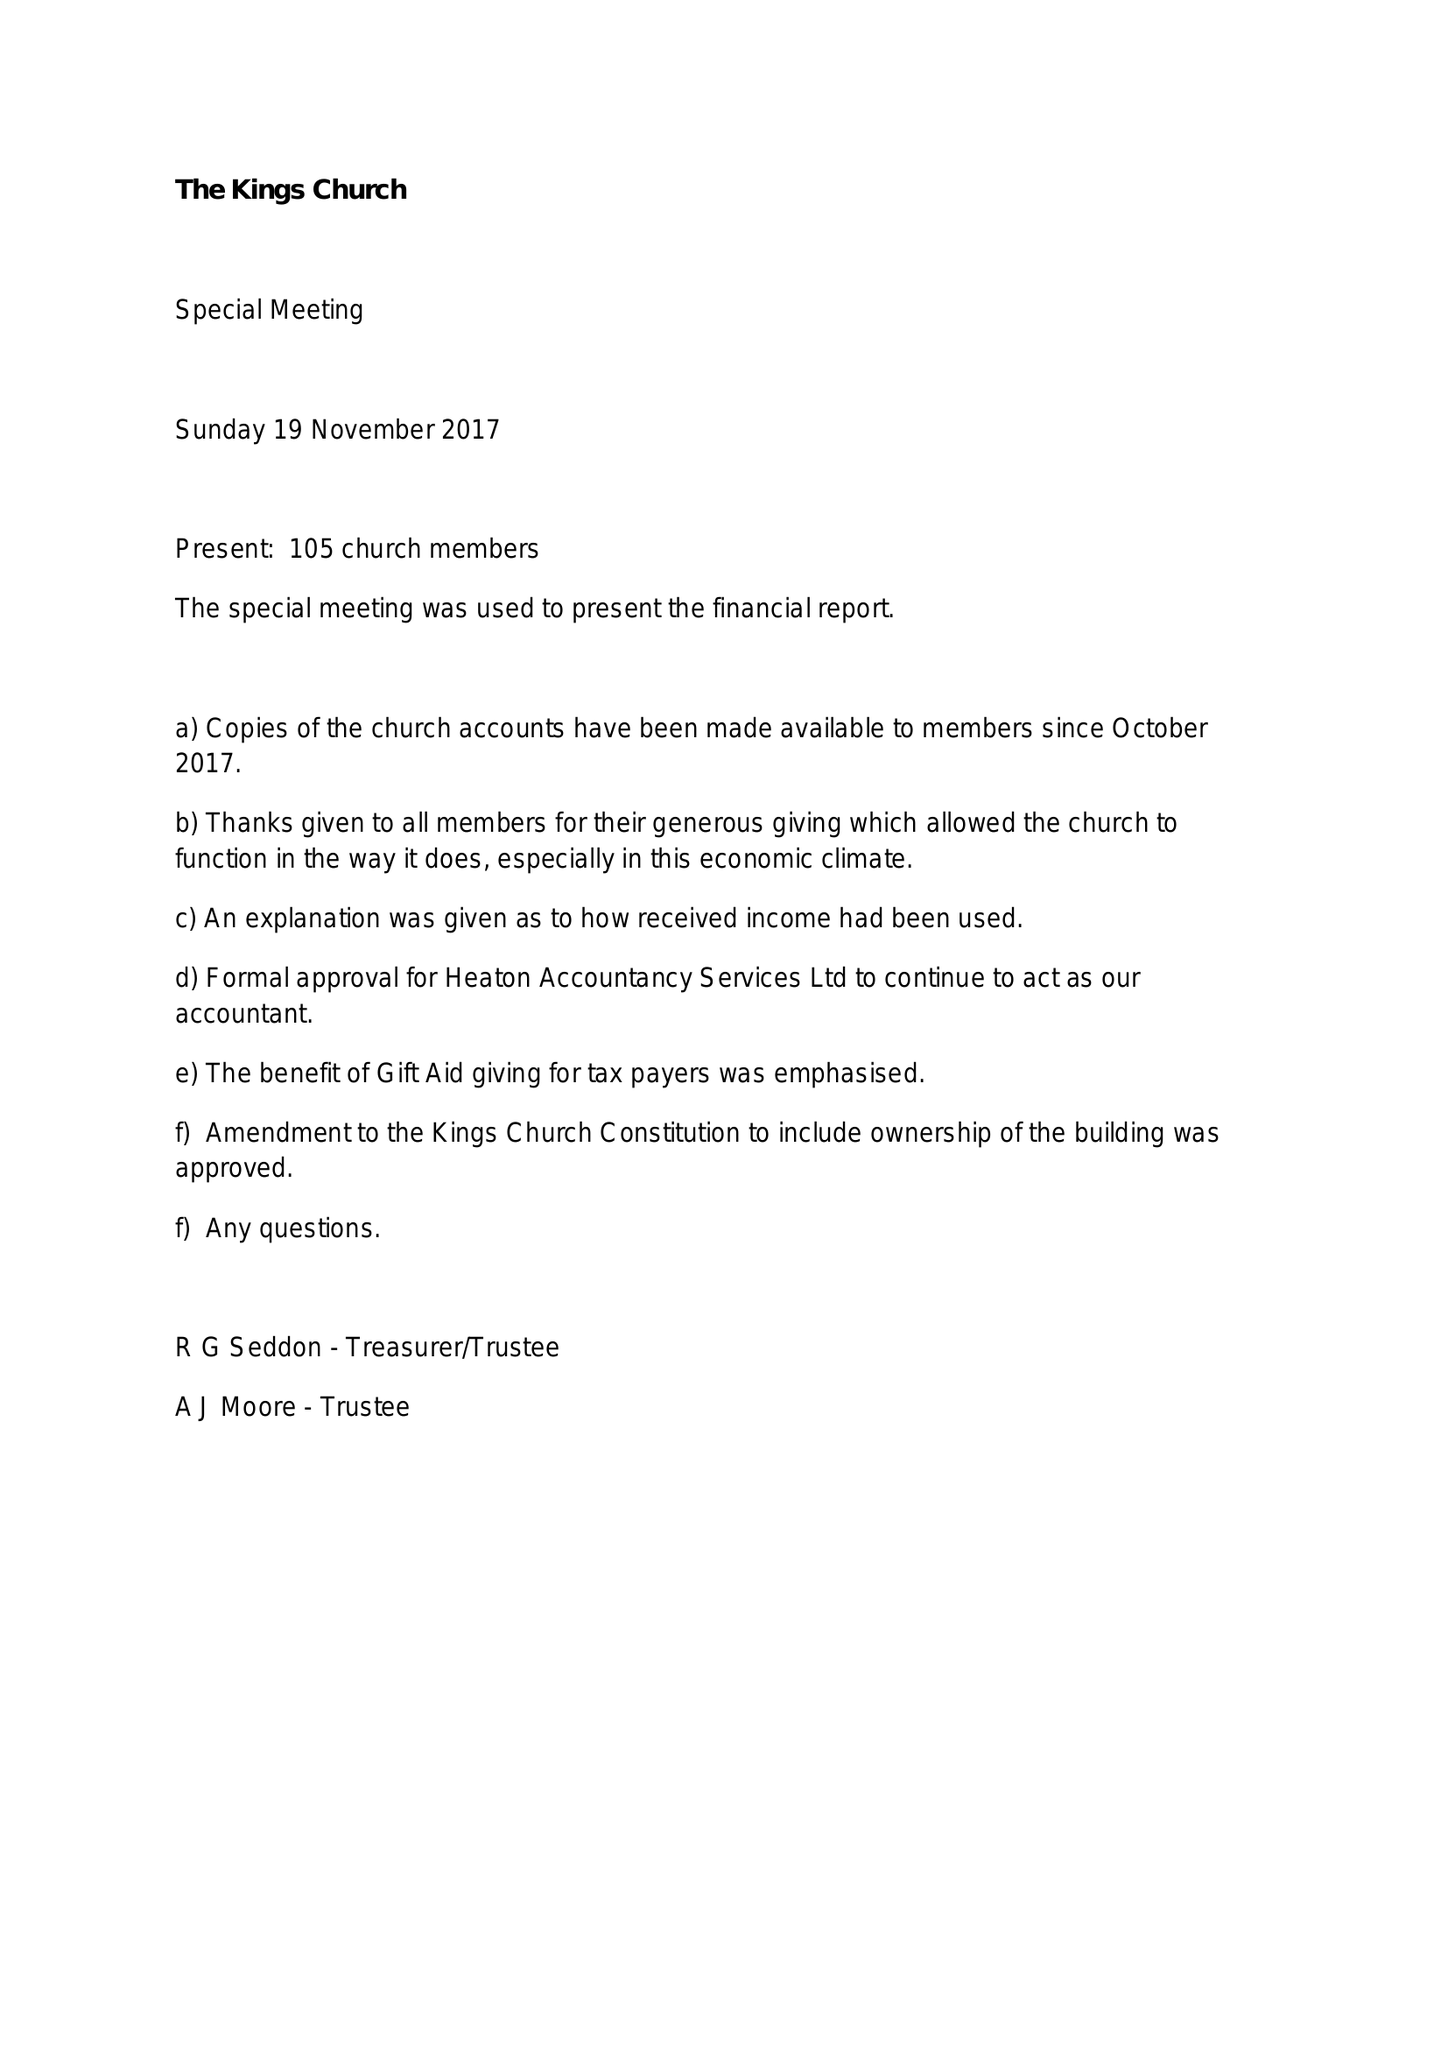What is the value for the address__street_line?
Answer the question using a single word or phrase. None 